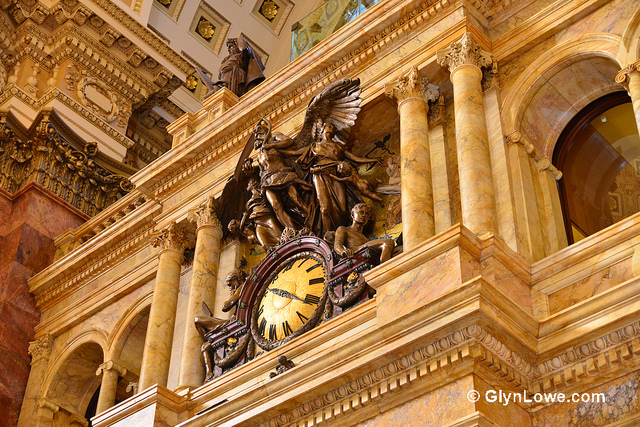Identify and read out the text in this image. GlynLOwe.com 